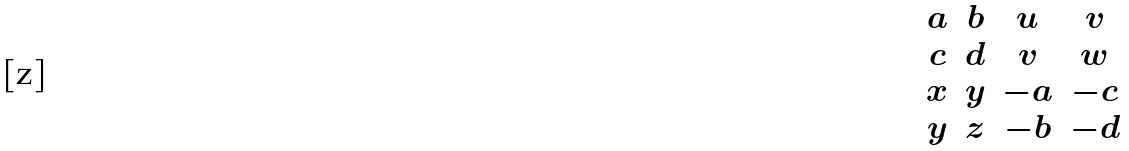Convert formula to latex. <formula><loc_0><loc_0><loc_500><loc_500>\begin{matrix} a & b & u & v \\ c & d & v & w \\ x & y & - a & - c \\ y & z & - b & - d \end{matrix}</formula> 